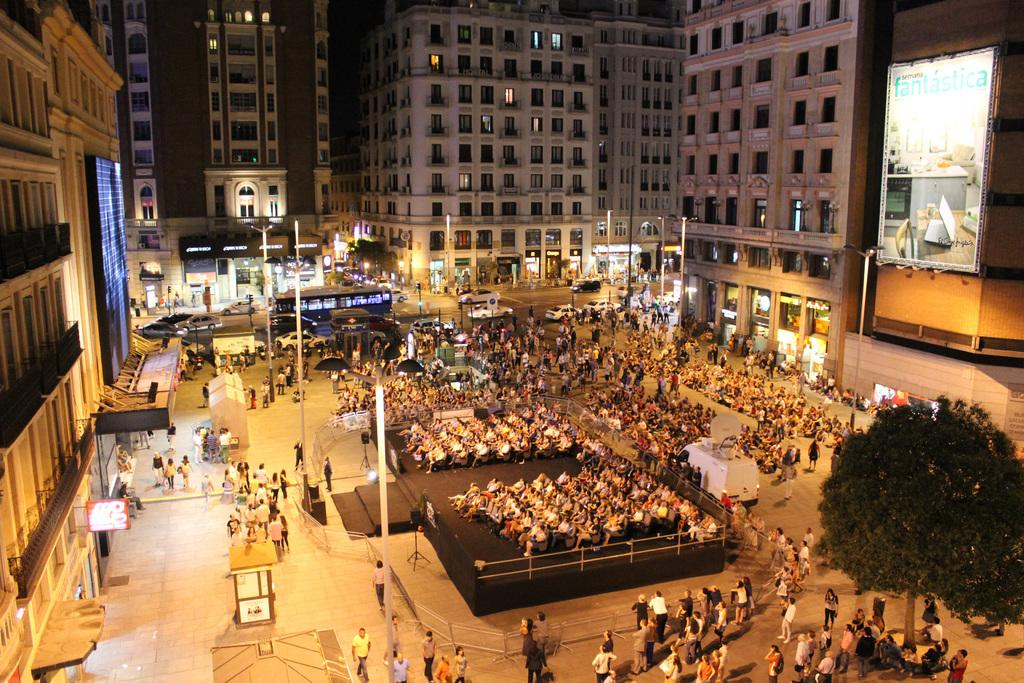Who or what can be seen in the image? There are people in the image. What else is visible on the road in the image? There are vehicles on the road in the image. What structures are present in the image? There are poles, buildings, and a tree in the image. Where is the library located in the image? There is no library present in the image. What type of secretary can be seen working in the image? There is no secretary present in the image. 